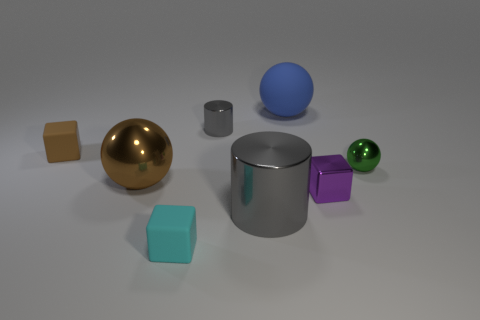How many other things are made of the same material as the blue object?
Offer a very short reply. 2. Are there more tiny green metal spheres that are behind the small gray shiny object than gray metal objects to the right of the blue rubber object?
Your answer should be very brief. No. What is the object behind the small gray metal cylinder made of?
Your answer should be compact. Rubber. Does the tiny purple object have the same shape as the tiny brown matte thing?
Provide a succinct answer. Yes. Is there anything else of the same color as the small cylinder?
Your answer should be very brief. Yes. What is the color of the big metal object that is the same shape as the tiny green object?
Make the answer very short. Brown. Is the number of small rubber blocks that are behind the blue thing greater than the number of cyan objects?
Ensure brevity in your answer.  No. The shiny sphere that is behind the big brown object is what color?
Offer a very short reply. Green. Is the purple metallic cube the same size as the cyan object?
Offer a terse response. Yes. What size is the purple shiny object?
Provide a succinct answer. Small. 